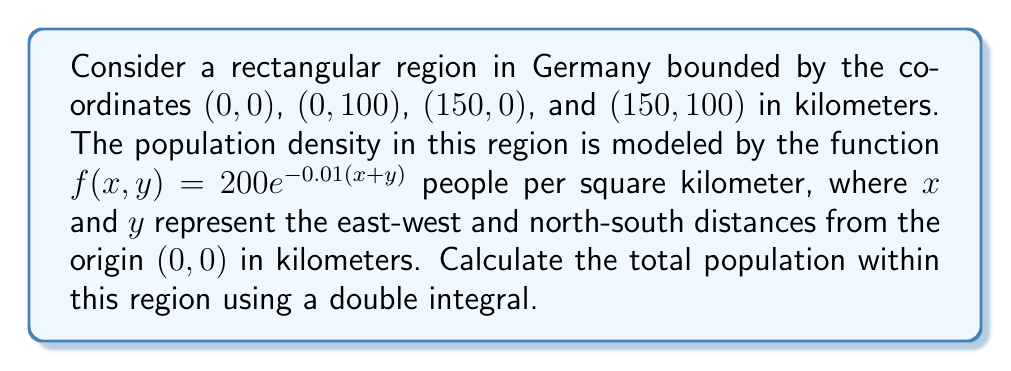Can you answer this question? To find the total population within the given region, we need to integrate the population density function over the entire area. We'll use a double integral for this purpose.

1) The region is a rectangle with bounds:
   $0 \leq x \leq 150$ and $0 \leq y \leq 100$

2) The population density function is:
   $f(x,y) = 200e^{-0.01(x+y)}$

3) The double integral to calculate the total population is:

   $$P = \int_{0}^{100} \int_{0}^{150} 200e^{-0.01(x+y)} dx dy$$

4) Let's solve the inner integral first (with respect to x):

   $$\int_{0}^{150} 200e^{-0.01(x+y)} dx = -20000e^{-0.01(x+y)} \bigg|_{0}^{150}$$
   $$= -20000(e^{-0.01(150+y)} - e^{-0.01y})$$
   $$= 20000e^{-0.01y}(1 - e^{-1.5})$$

5) Now we integrate this result with respect to y:

   $$P = \int_{0}^{100} 20000e^{-0.01y}(1 - e^{-1.5}) dy$$
   $$= 20000(1 - e^{-1.5}) \cdot (-100e^{-0.01y}) \bigg|_{0}^{100}$$
   $$= 20000(1 - e^{-1.5}) \cdot (100 - 100e^{-1})$$
   $$= 2000000(1 - e^{-1.5})(1 - e^{-1})$$

6) Evaluate this expression:

   $$P \approx 2000000 \cdot 0.7769 \cdot 0.6321 \approx 982,184$$
Answer: The total population within the given region is approximately 982,184 people. 